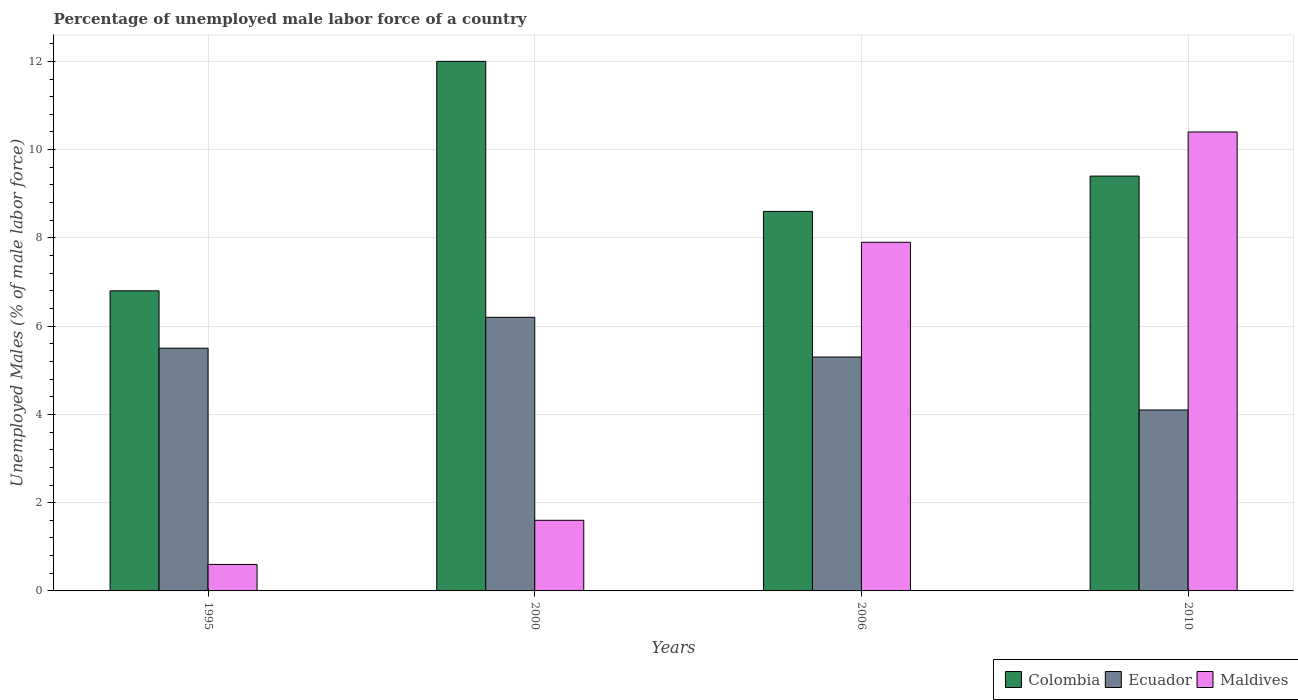How many different coloured bars are there?
Your response must be concise. 3. How many groups of bars are there?
Provide a succinct answer. 4. Are the number of bars on each tick of the X-axis equal?
Make the answer very short. Yes. How many bars are there on the 4th tick from the right?
Your answer should be very brief. 3. What is the label of the 3rd group of bars from the left?
Ensure brevity in your answer.  2006. In how many cases, is the number of bars for a given year not equal to the number of legend labels?
Make the answer very short. 0. What is the percentage of unemployed male labor force in Ecuador in 1995?
Ensure brevity in your answer.  5.5. Across all years, what is the maximum percentage of unemployed male labor force in Ecuador?
Provide a short and direct response. 6.2. Across all years, what is the minimum percentage of unemployed male labor force in Maldives?
Make the answer very short. 0.6. In which year was the percentage of unemployed male labor force in Colombia maximum?
Provide a short and direct response. 2000. In which year was the percentage of unemployed male labor force in Ecuador minimum?
Give a very brief answer. 2010. What is the total percentage of unemployed male labor force in Maldives in the graph?
Your answer should be compact. 20.5. What is the difference between the percentage of unemployed male labor force in Ecuador in 1995 and that in 2006?
Provide a short and direct response. 0.2. What is the difference between the percentage of unemployed male labor force in Colombia in 2006 and the percentage of unemployed male labor force in Ecuador in 1995?
Provide a short and direct response. 3.1. What is the average percentage of unemployed male labor force in Ecuador per year?
Your response must be concise. 5.27. In the year 2000, what is the difference between the percentage of unemployed male labor force in Colombia and percentage of unemployed male labor force in Ecuador?
Offer a very short reply. 5.8. In how many years, is the percentage of unemployed male labor force in Maldives greater than 12 %?
Offer a terse response. 0. What is the ratio of the percentage of unemployed male labor force in Maldives in 2000 to that in 2006?
Your answer should be very brief. 0.2. Is the percentage of unemployed male labor force in Ecuador in 1995 less than that in 2000?
Give a very brief answer. Yes. What is the difference between the highest and the second highest percentage of unemployed male labor force in Colombia?
Your answer should be compact. 2.6. What is the difference between the highest and the lowest percentage of unemployed male labor force in Colombia?
Offer a terse response. 5.2. In how many years, is the percentage of unemployed male labor force in Ecuador greater than the average percentage of unemployed male labor force in Ecuador taken over all years?
Keep it short and to the point. 3. What does the 1st bar from the left in 2000 represents?
Offer a terse response. Colombia. What does the 2nd bar from the right in 2000 represents?
Offer a terse response. Ecuador. How many years are there in the graph?
Offer a terse response. 4. Does the graph contain grids?
Make the answer very short. Yes. How are the legend labels stacked?
Give a very brief answer. Horizontal. What is the title of the graph?
Your answer should be very brief. Percentage of unemployed male labor force of a country. Does "Iran" appear as one of the legend labels in the graph?
Make the answer very short. No. What is the label or title of the Y-axis?
Keep it short and to the point. Unemployed Males (% of male labor force). What is the Unemployed Males (% of male labor force) of Colombia in 1995?
Your answer should be compact. 6.8. What is the Unemployed Males (% of male labor force) in Ecuador in 1995?
Your answer should be compact. 5.5. What is the Unemployed Males (% of male labor force) of Maldives in 1995?
Your answer should be very brief. 0.6. What is the Unemployed Males (% of male labor force) of Ecuador in 2000?
Offer a terse response. 6.2. What is the Unemployed Males (% of male labor force) in Maldives in 2000?
Give a very brief answer. 1.6. What is the Unemployed Males (% of male labor force) of Colombia in 2006?
Provide a succinct answer. 8.6. What is the Unemployed Males (% of male labor force) of Ecuador in 2006?
Your answer should be very brief. 5.3. What is the Unemployed Males (% of male labor force) in Maldives in 2006?
Provide a succinct answer. 7.9. What is the Unemployed Males (% of male labor force) of Colombia in 2010?
Make the answer very short. 9.4. What is the Unemployed Males (% of male labor force) of Ecuador in 2010?
Offer a very short reply. 4.1. What is the Unemployed Males (% of male labor force) of Maldives in 2010?
Your response must be concise. 10.4. Across all years, what is the maximum Unemployed Males (% of male labor force) of Ecuador?
Provide a succinct answer. 6.2. Across all years, what is the maximum Unemployed Males (% of male labor force) in Maldives?
Your answer should be very brief. 10.4. Across all years, what is the minimum Unemployed Males (% of male labor force) of Colombia?
Your response must be concise. 6.8. Across all years, what is the minimum Unemployed Males (% of male labor force) in Ecuador?
Offer a terse response. 4.1. Across all years, what is the minimum Unemployed Males (% of male labor force) of Maldives?
Keep it short and to the point. 0.6. What is the total Unemployed Males (% of male labor force) of Colombia in the graph?
Provide a short and direct response. 36.8. What is the total Unemployed Males (% of male labor force) of Ecuador in the graph?
Provide a short and direct response. 21.1. What is the difference between the Unemployed Males (% of male labor force) of Ecuador in 1995 and that in 2000?
Ensure brevity in your answer.  -0.7. What is the difference between the Unemployed Males (% of male labor force) of Maldives in 1995 and that in 2000?
Offer a terse response. -1. What is the difference between the Unemployed Males (% of male labor force) of Colombia in 1995 and that in 2006?
Provide a succinct answer. -1.8. What is the difference between the Unemployed Males (% of male labor force) of Ecuador in 1995 and that in 2006?
Keep it short and to the point. 0.2. What is the difference between the Unemployed Males (% of male labor force) of Maldives in 1995 and that in 2006?
Keep it short and to the point. -7.3. What is the difference between the Unemployed Males (% of male labor force) in Maldives in 1995 and that in 2010?
Your answer should be very brief. -9.8. What is the difference between the Unemployed Males (% of male labor force) of Colombia in 2000 and that in 2006?
Your answer should be very brief. 3.4. What is the difference between the Unemployed Males (% of male labor force) of Ecuador in 2000 and that in 2006?
Offer a very short reply. 0.9. What is the difference between the Unemployed Males (% of male labor force) of Colombia in 2000 and that in 2010?
Offer a very short reply. 2.6. What is the difference between the Unemployed Males (% of male labor force) of Maldives in 2000 and that in 2010?
Your response must be concise. -8.8. What is the difference between the Unemployed Males (% of male labor force) of Colombia in 2006 and that in 2010?
Keep it short and to the point. -0.8. What is the difference between the Unemployed Males (% of male labor force) in Ecuador in 2006 and that in 2010?
Make the answer very short. 1.2. What is the difference between the Unemployed Males (% of male labor force) of Maldives in 2006 and that in 2010?
Provide a succinct answer. -2.5. What is the difference between the Unemployed Males (% of male labor force) of Colombia in 1995 and the Unemployed Males (% of male labor force) of Ecuador in 2000?
Keep it short and to the point. 0.6. What is the difference between the Unemployed Males (% of male labor force) in Ecuador in 1995 and the Unemployed Males (% of male labor force) in Maldives in 2000?
Your answer should be compact. 3.9. What is the difference between the Unemployed Males (% of male labor force) in Colombia in 1995 and the Unemployed Males (% of male labor force) in Ecuador in 2006?
Provide a succinct answer. 1.5. What is the difference between the Unemployed Males (% of male labor force) of Ecuador in 1995 and the Unemployed Males (% of male labor force) of Maldives in 2006?
Your response must be concise. -2.4. What is the difference between the Unemployed Males (% of male labor force) in Colombia in 1995 and the Unemployed Males (% of male labor force) in Maldives in 2010?
Offer a terse response. -3.6. What is the difference between the Unemployed Males (% of male labor force) of Ecuador in 1995 and the Unemployed Males (% of male labor force) of Maldives in 2010?
Your answer should be compact. -4.9. What is the difference between the Unemployed Males (% of male labor force) in Colombia in 2000 and the Unemployed Males (% of male labor force) in Ecuador in 2006?
Offer a very short reply. 6.7. What is the difference between the Unemployed Males (% of male labor force) in Colombia in 2000 and the Unemployed Males (% of male labor force) in Ecuador in 2010?
Give a very brief answer. 7.9. What is the difference between the Unemployed Males (% of male labor force) of Colombia in 2006 and the Unemployed Males (% of male labor force) of Ecuador in 2010?
Offer a very short reply. 4.5. What is the difference between the Unemployed Males (% of male labor force) of Colombia in 2006 and the Unemployed Males (% of male labor force) of Maldives in 2010?
Your answer should be very brief. -1.8. What is the average Unemployed Males (% of male labor force) of Ecuador per year?
Your answer should be very brief. 5.28. What is the average Unemployed Males (% of male labor force) in Maldives per year?
Give a very brief answer. 5.12. In the year 2000, what is the difference between the Unemployed Males (% of male labor force) of Colombia and Unemployed Males (% of male labor force) of Maldives?
Your answer should be very brief. 10.4. In the year 2000, what is the difference between the Unemployed Males (% of male labor force) of Ecuador and Unemployed Males (% of male labor force) of Maldives?
Offer a very short reply. 4.6. In the year 2006, what is the difference between the Unemployed Males (% of male labor force) of Ecuador and Unemployed Males (% of male labor force) of Maldives?
Make the answer very short. -2.6. In the year 2010, what is the difference between the Unemployed Males (% of male labor force) of Colombia and Unemployed Males (% of male labor force) of Maldives?
Your response must be concise. -1. What is the ratio of the Unemployed Males (% of male labor force) in Colombia in 1995 to that in 2000?
Give a very brief answer. 0.57. What is the ratio of the Unemployed Males (% of male labor force) of Ecuador in 1995 to that in 2000?
Give a very brief answer. 0.89. What is the ratio of the Unemployed Males (% of male labor force) in Colombia in 1995 to that in 2006?
Your answer should be compact. 0.79. What is the ratio of the Unemployed Males (% of male labor force) in Ecuador in 1995 to that in 2006?
Keep it short and to the point. 1.04. What is the ratio of the Unemployed Males (% of male labor force) of Maldives in 1995 to that in 2006?
Offer a terse response. 0.08. What is the ratio of the Unemployed Males (% of male labor force) of Colombia in 1995 to that in 2010?
Offer a terse response. 0.72. What is the ratio of the Unemployed Males (% of male labor force) of Ecuador in 1995 to that in 2010?
Offer a terse response. 1.34. What is the ratio of the Unemployed Males (% of male labor force) in Maldives in 1995 to that in 2010?
Provide a succinct answer. 0.06. What is the ratio of the Unemployed Males (% of male labor force) in Colombia in 2000 to that in 2006?
Offer a terse response. 1.4. What is the ratio of the Unemployed Males (% of male labor force) in Ecuador in 2000 to that in 2006?
Make the answer very short. 1.17. What is the ratio of the Unemployed Males (% of male labor force) of Maldives in 2000 to that in 2006?
Ensure brevity in your answer.  0.2. What is the ratio of the Unemployed Males (% of male labor force) in Colombia in 2000 to that in 2010?
Keep it short and to the point. 1.28. What is the ratio of the Unemployed Males (% of male labor force) in Ecuador in 2000 to that in 2010?
Your response must be concise. 1.51. What is the ratio of the Unemployed Males (% of male labor force) in Maldives in 2000 to that in 2010?
Your response must be concise. 0.15. What is the ratio of the Unemployed Males (% of male labor force) of Colombia in 2006 to that in 2010?
Offer a very short reply. 0.91. What is the ratio of the Unemployed Males (% of male labor force) in Ecuador in 2006 to that in 2010?
Your answer should be very brief. 1.29. What is the ratio of the Unemployed Males (% of male labor force) of Maldives in 2006 to that in 2010?
Your answer should be compact. 0.76. What is the difference between the highest and the second highest Unemployed Males (% of male labor force) of Colombia?
Provide a short and direct response. 2.6. What is the difference between the highest and the second highest Unemployed Males (% of male labor force) of Ecuador?
Provide a short and direct response. 0.7. 